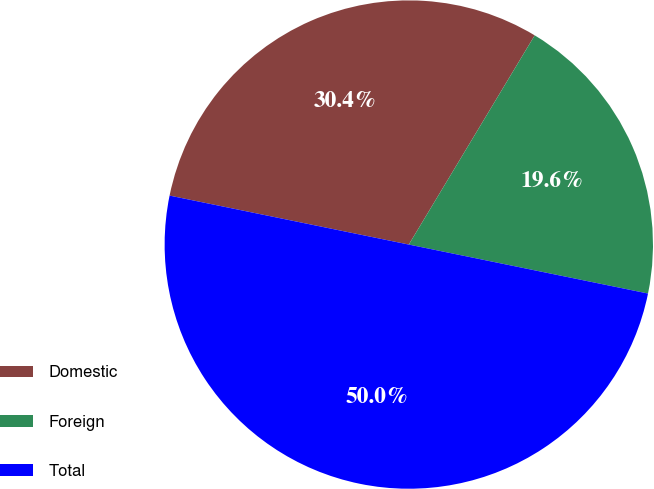Convert chart. <chart><loc_0><loc_0><loc_500><loc_500><pie_chart><fcel>Domestic<fcel>Foreign<fcel>Total<nl><fcel>30.41%<fcel>19.59%<fcel>50.0%<nl></chart> 